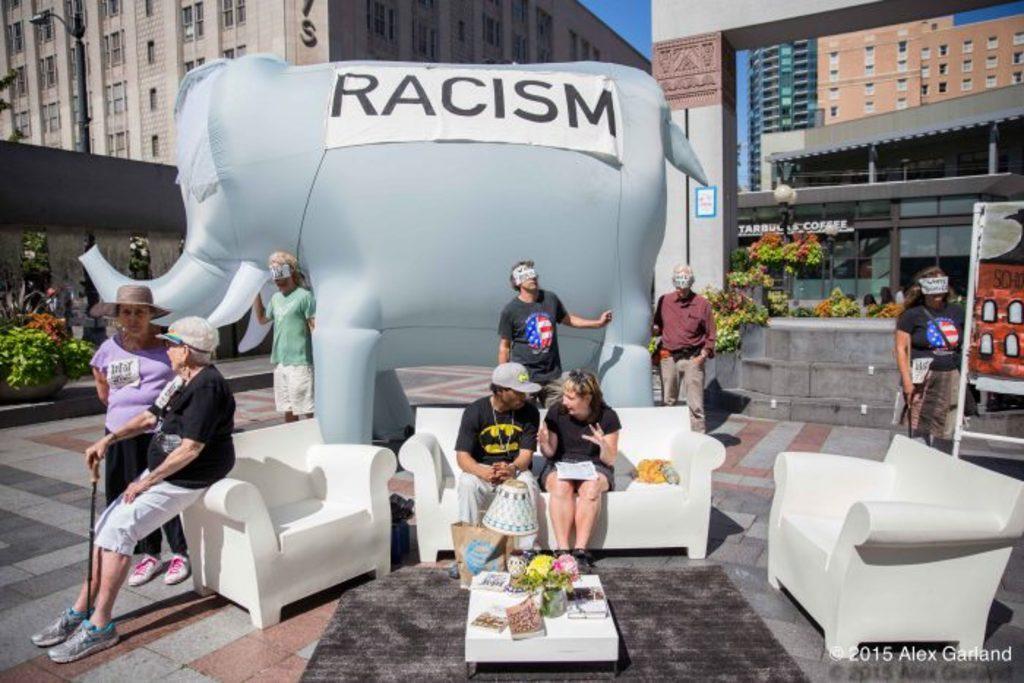Describe this image in one or two sentences. In the image there are sofas in the foreground and there are two people sitting on the sofa which is in the middle, in front of them there is a table and on the table there are some objects. Around the sofas there are few people and behind them there is a balloon in an elephant shape, around the balloon there are some stores and buildings. 